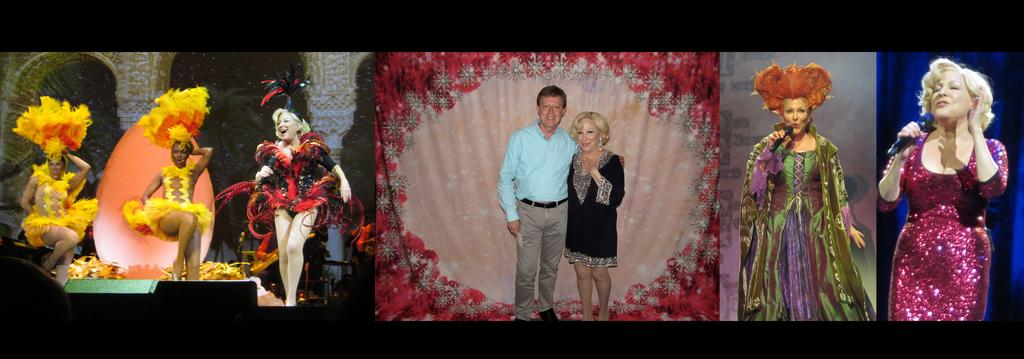How many people are in the image? There are two people standing in the center of the image. What are the two women doing in the image? Two women are singing in the image. What are the other three women doing in the image? Three women are dancing in the image. What part of the road can be seen in the image? There is no road present in the image; it features two women singing and three women dancing. 